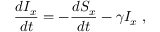<formula> <loc_0><loc_0><loc_500><loc_500>\frac { d I _ { x } } { d t } = - \frac { d S _ { x } } { d t } - \gamma I _ { x } \, ,</formula> 